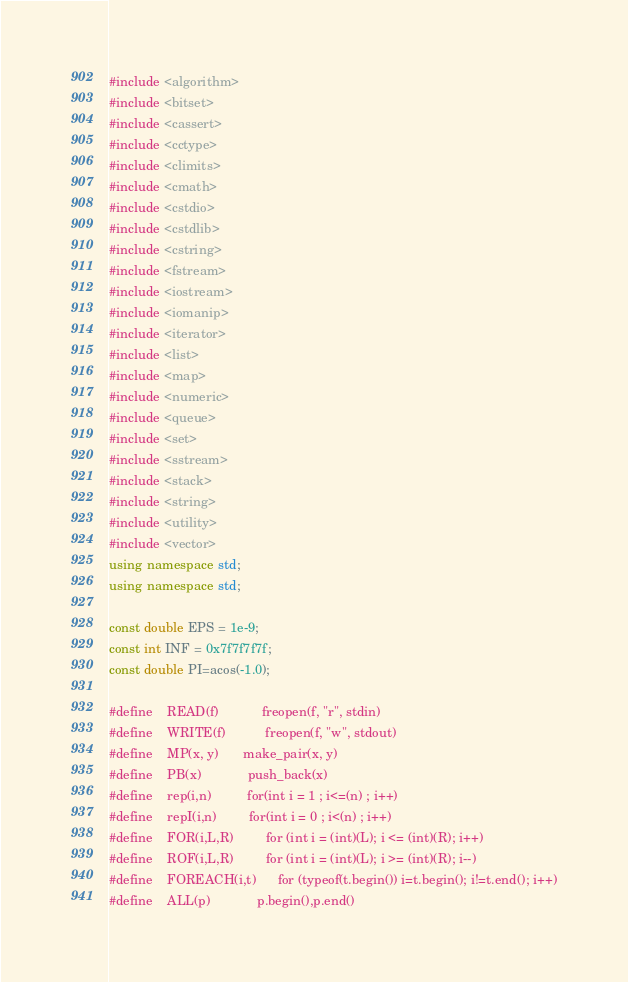<code> <loc_0><loc_0><loc_500><loc_500><_C++_>#include <algorithm>
#include <bitset>
#include <cassert>
#include <cctype>
#include <climits>
#include <cmath>
#include <cstdio>
#include <cstdlib>
#include <cstring>
#include <fstream>
#include <iostream>
#include <iomanip>
#include <iterator>
#include <list>
#include <map>
#include <numeric>
#include <queue>
#include <set>
#include <sstream>
#include <stack>
#include <string>
#include <utility>
#include <vector>
using namespace std;
using namespace std;

const double EPS = 1e-9;
const int INF = 0x7f7f7f7f;
const double PI=acos(-1.0);

#define    READ(f) 	         freopen(f, "r", stdin)
#define    WRITE(f)   	     freopen(f, "w", stdout)
#define    MP(x, y) 	     make_pair(x, y)
#define    PB(x)             push_back(x)
#define    rep(i,n)          for(int i = 1 ; i<=(n) ; i++)
#define    repI(i,n)         for(int i = 0 ; i<(n) ; i++)
#define    FOR(i,L,R) 	     for (int i = (int)(L); i <= (int)(R); i++)
#define    ROF(i,L,R) 	     for (int i = (int)(L); i >= (int)(R); i--)
#define    FOREACH(i,t)      for (typeof(t.begin()) i=t.begin(); i!=t.end(); i++)
#define    ALL(p) 	         p.begin(),p.end()</code> 